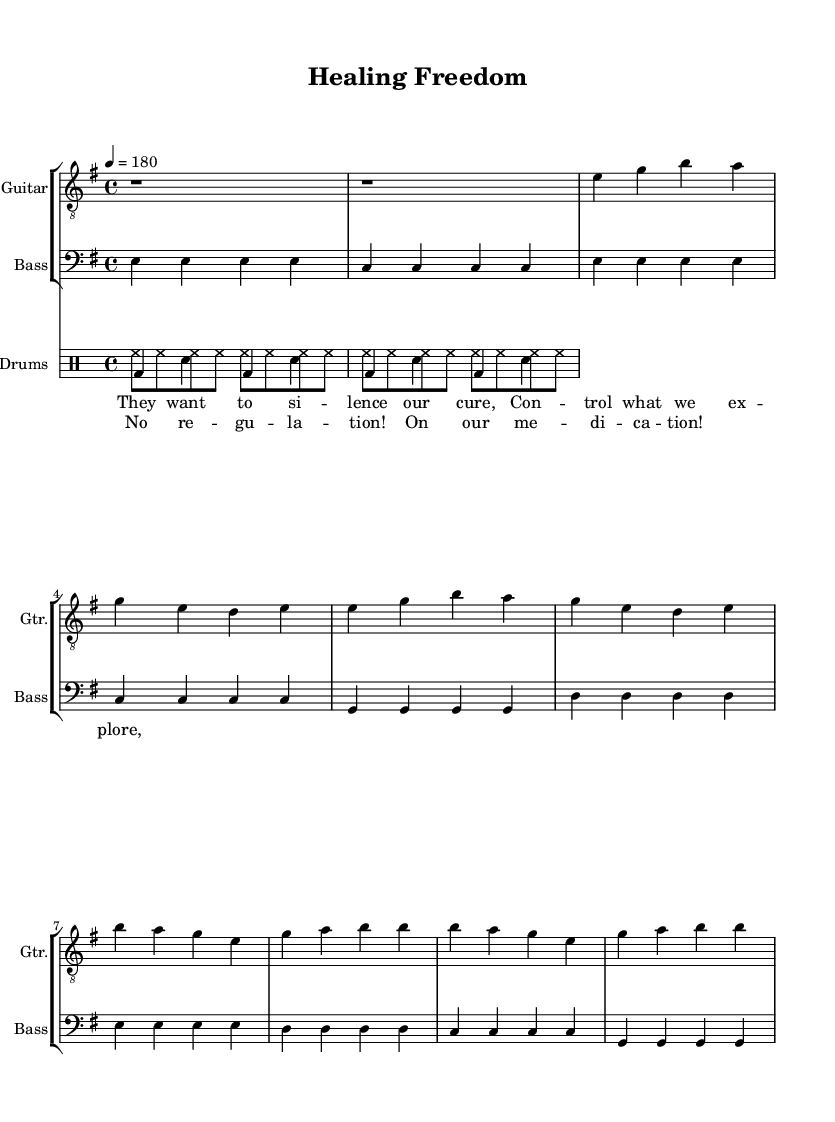What is the key signature of this music? The key signature is E minor, as indicated by the presence of one sharp (F#). This can be found in the initial setup of the music (global section) where it specifies \key e \minor.
Answer: E minor What is the time signature of this piece? The time signature is 4/4, as shown in the global section of the music where it states \time 4/4. This means there are four beats in a measure, and the quarter note gets one beat.
Answer: 4/4 What is the tempo marking for this song? The tempo marking is 180, indicated in the global section with \tempo 4 = 180, meaning the piece should be played at 180 beats per minute.
Answer: 180 How many measures are in the verse section? The verse section consists of 4 measures, each containing a set number of beats as indicated by the notation. Counting the measures from the verse lyrics, we see it spans from the first note to the end of the stanza, making four measures in total.
Answer: 4 What type of music is this piece categorized as? This piece is categorized as Punk, which is typically characterized by its fast tempos, strong beats, and rebellious lyrics, fitting the theme of anti-establishment sentiments visible in the lyrics and composition style.
Answer: Punk In which section do we find the lyrics "No regulation!"? The lyrics "No regulation!" are found in the chorus section. By observing the layout of the score, the lyrics follow the structure that corresponds to the chorus part of the song.
Answer: Chorus What is the bass note at the beginning of the intro? The bass note at the beginning of the intro is E. This can be confirmed by looking at the bassMusic section where the first notes are all E and indicate the starting point for the bass line.
Answer: E 